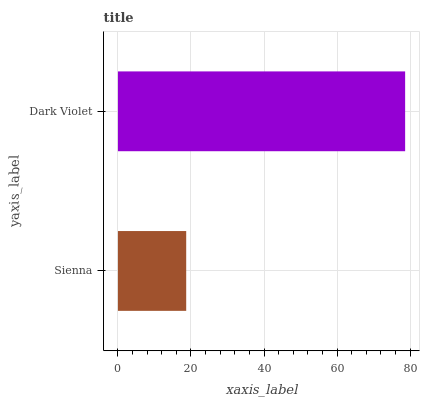Is Sienna the minimum?
Answer yes or no. Yes. Is Dark Violet the maximum?
Answer yes or no. Yes. Is Dark Violet the minimum?
Answer yes or no. No. Is Dark Violet greater than Sienna?
Answer yes or no. Yes. Is Sienna less than Dark Violet?
Answer yes or no. Yes. Is Sienna greater than Dark Violet?
Answer yes or no. No. Is Dark Violet less than Sienna?
Answer yes or no. No. Is Dark Violet the high median?
Answer yes or no. Yes. Is Sienna the low median?
Answer yes or no. Yes. Is Sienna the high median?
Answer yes or no. No. Is Dark Violet the low median?
Answer yes or no. No. 